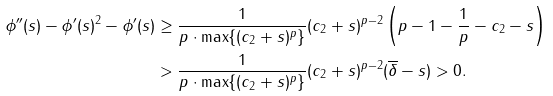Convert formula to latex. <formula><loc_0><loc_0><loc_500><loc_500>\phi ^ { \prime \prime } ( s ) - \phi ^ { \prime } ( s ) ^ { 2 } - \phi ^ { \prime } ( s ) & \geq \frac { 1 } { p \cdot \max \{ ( c _ { 2 } + s ) ^ { p } \} } ( c _ { 2 } + s ) ^ { p - 2 } \left ( p - 1 - \frac { 1 } { p } - c _ { 2 } - s \right ) \\ & > \frac { 1 } { p \cdot \max \{ ( c _ { 2 } + s ) ^ { p } \} } ( c _ { 2 } + s ) ^ { p - 2 } ( \overline { \delta } - s ) > 0 .</formula> 